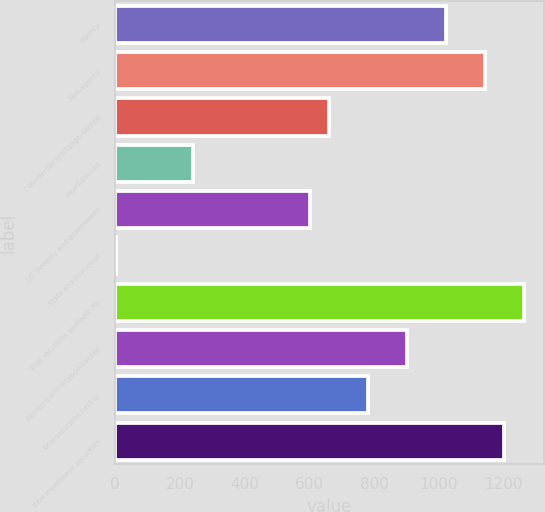Convert chart to OTSL. <chart><loc_0><loc_0><loc_500><loc_500><bar_chart><fcel>Agency<fcel>Non-agency<fcel>Commercial mortgage-backed<fcel>Asset-backed<fcel>US Treasury and government<fcel>State and municipal<fcel>Total securities available for<fcel>Residential mortgage-backed<fcel>Total securities held to<fcel>Total investment securities<nl><fcel>1021<fcel>1141<fcel>661<fcel>241<fcel>601<fcel>1<fcel>1261<fcel>901<fcel>781<fcel>1201<nl></chart> 